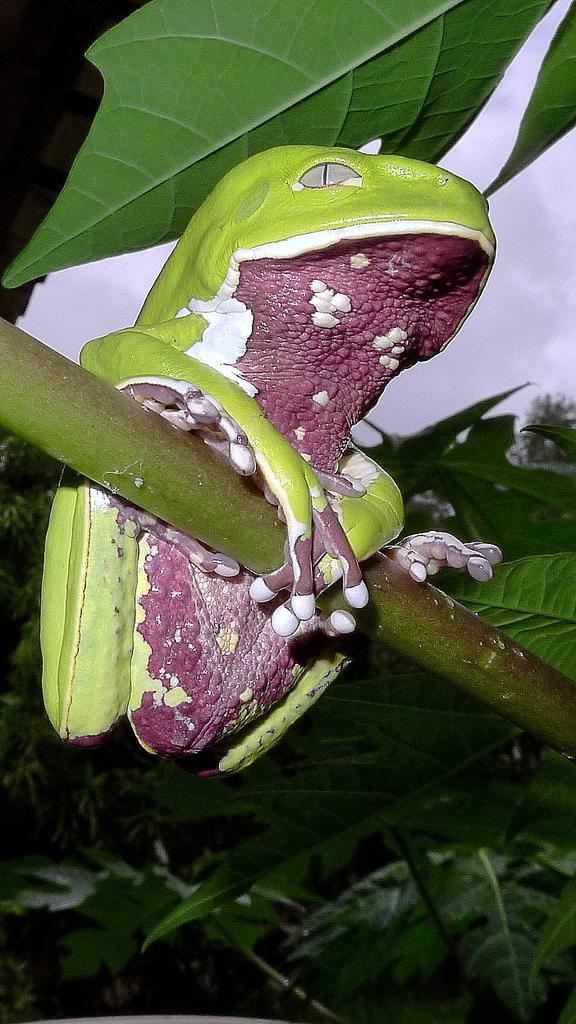What type of toy is in the image? There is a frog toy in the image. Where is the frog toy located? The frog toy is on a tree stem. What can be seen at the top of the tree in the image? There are green leaves at the top of the tree in the image. How many tickets can be seen hanging from the tree in the image? There are no tickets present in the image; it features a frog toy on a tree stem with green leaves at the top. What type of cake is visible on the tree in the image? There is no cake present in the image; it features a frog toy on a tree stem with green leaves at the top. 